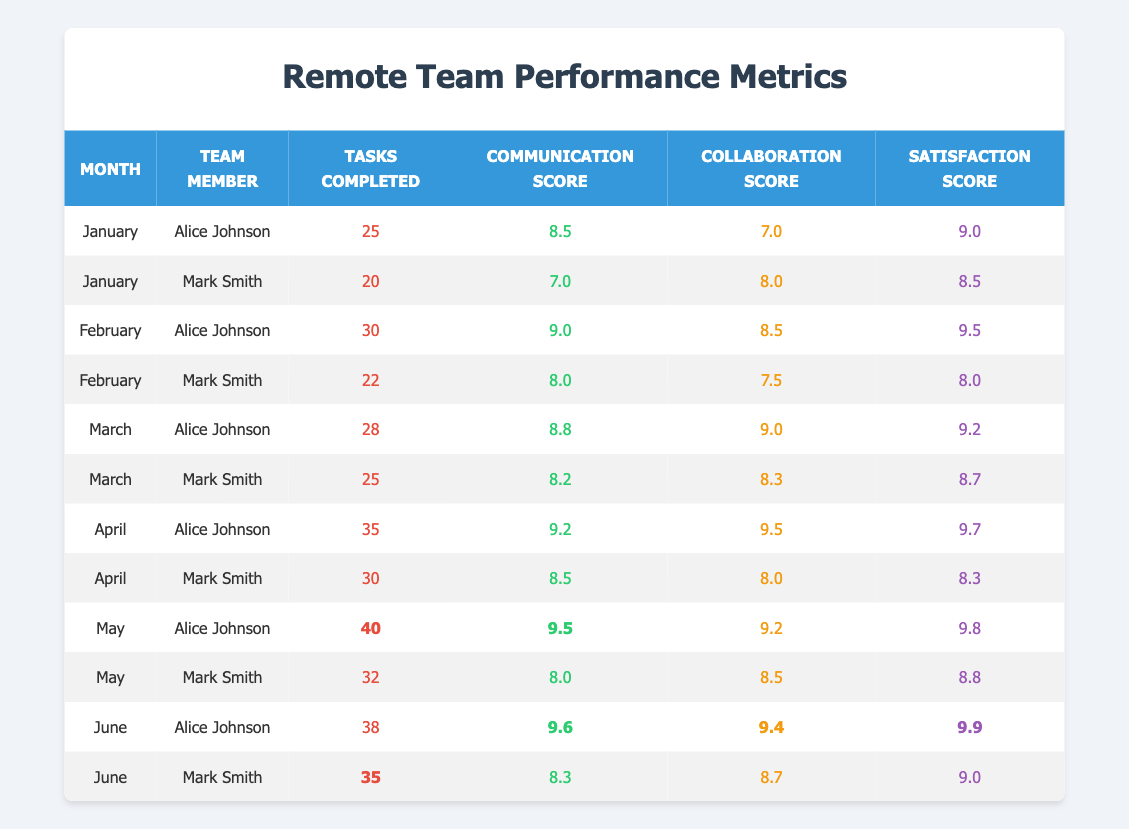What is the total number of tasks completed by Alice Johnson from January to June? To find the total tasks completed by Alice Johnson, add her tasks for each month: 25 (January) + 30 (February) + 28 (March) + 35 (April) + 40 (May) + 38 (June) = 196.
Answer: 196 What was Mark Smith's highest communication score and in which month did he achieve it? Mark Smith's communication scores were: January - 7.0, February - 8.0, March - 8.2, April - 8.5, May - 8.0, June - 8.3. The highest is 8.5 in April.
Answer: 8.5 in April What is the average satisfaction score for Alice Johnson over the six months? To calculate the average satisfaction score for Alice Johnson, sum her scores: 9.0 + 9.5 + 9.2 + 9.7 + 9.8 + 9.9 = 57.1. Then divide by the number of months (6): 57.1 / 6 = 9.52.
Answer: 9.52 Did Mark Smith complete more than 30 tasks in any month? Checking Mark Smith's tasks month by month: January - 20, February - 22, March - 25, April - 30, May - 32, June - 35. He completed more than 30 tasks in May and June.
Answer: Yes What is the difference in task completion between Alice Johnson and Mark Smith in May? In May, Alice completed 40 tasks and Mark completed 32 tasks. The difference is 40 - 32 = 8 tasks.
Answer: 8 tasks In which month did both team members achieve their highest satisfaction scores? Checking the satisfaction scores shows: Alice's highest is 9.9 in June, and Mark's highest is 9.0 in June. Both had their highest in June.
Answer: June Calculate the overall average collaboration score for the team across all months. Summing all collaboration scores: 7.0 + 8.0 + 8.5 + 7.5 + 9.0 + 8.3 + 9.5 + 8.0 + 9.2 + 8.5 + 9.4 + 8.7 = 100.0. There are 12 scores, so divide by 12 to get 100.0 / 12 = 8.33.
Answer: 8.33 Was the satisfaction score for either team member ever below 8.0? Reviewing each satisfaction score: Mark Smith had 8.5 in January, 8.0 in February, and none below 8.0. Alice Johnson never had a score below 9.0. Therefore, yes, Mark's score was below 8.0 in February.
Answer: Yes What was Alice Johnson's average communication score over the six months? Alice's communication scores are: 8.5 + 9.0 + 8.8 + 9.2 + 9.5 + 9.6 = 54.6. Divide by 6 for average: 54.6 / 6 = 9.1.
Answer: 9.1 Which month had the highest combined tasks completed by both team members? Calculating total tasks by month: January (25 + 20 = 45), February (30 + 22 = 52), March (28 + 25 = 53), April (35 + 30 = 65), May (40 + 32 = 72), June (38 + 35 = 73). The highest combined tasks of 73 is in June.
Answer: June 